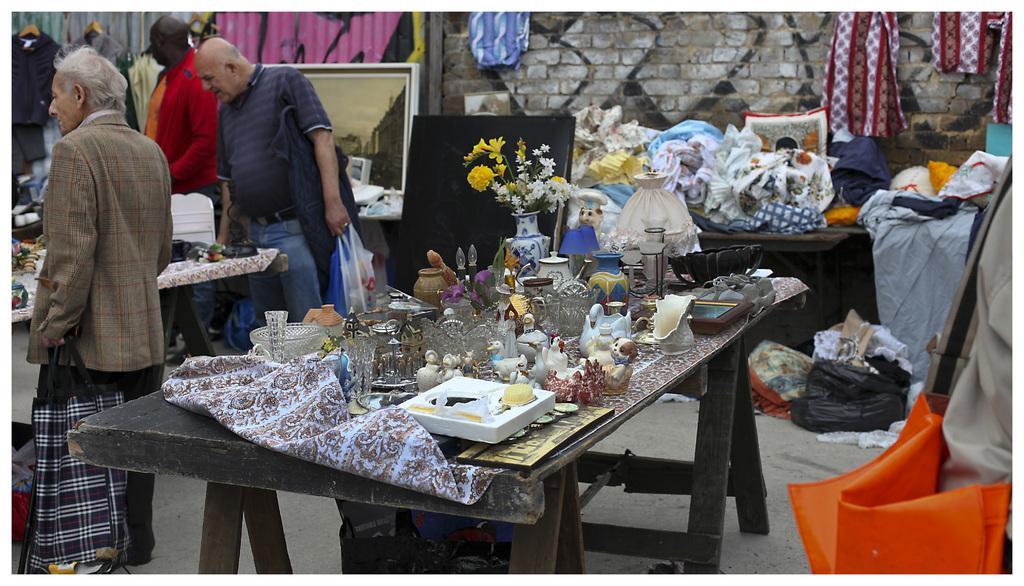How would you summarize this image in a sentence or two? On the left side we can see three persons were standing around the table. in center we can see table,on table we can see few objects like frame,flower vase,some pot etc. And coming to the background we can see some clothes on the table,board,photo frame,graffiti,wall etc. 